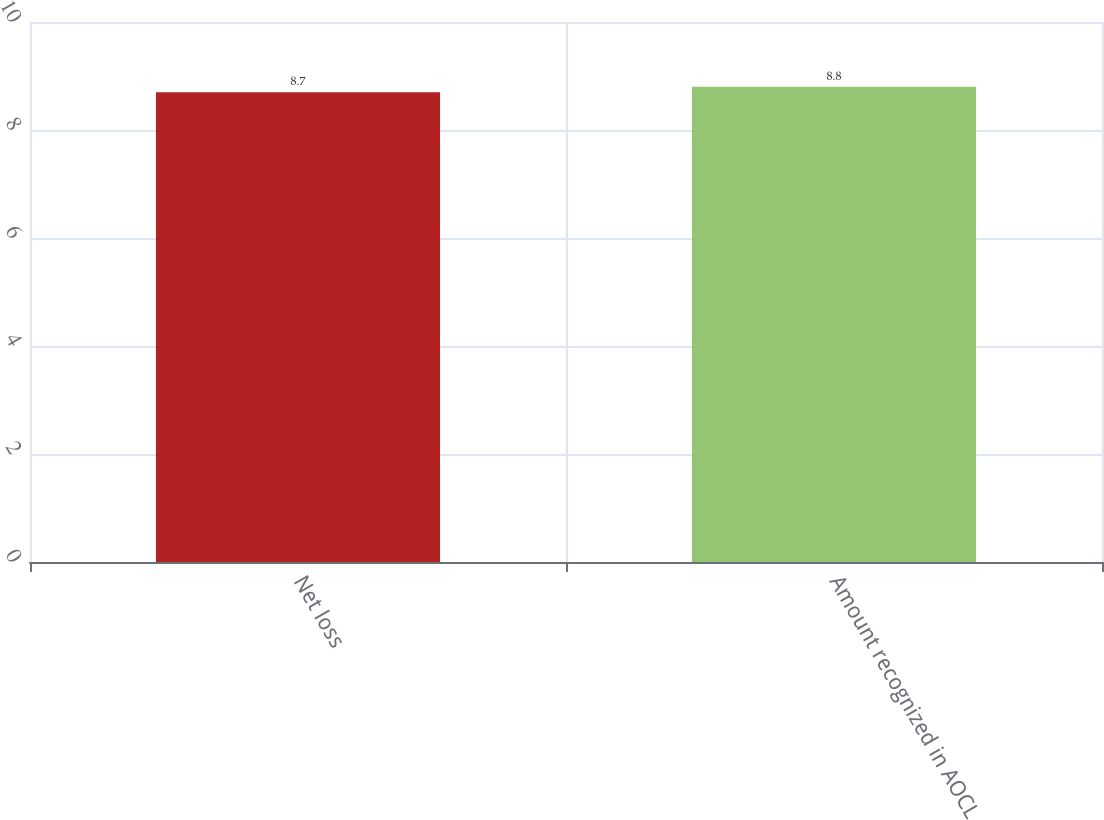Convert chart to OTSL. <chart><loc_0><loc_0><loc_500><loc_500><bar_chart><fcel>Net loss<fcel>Amount recognized in AOCL<nl><fcel>8.7<fcel>8.8<nl></chart> 